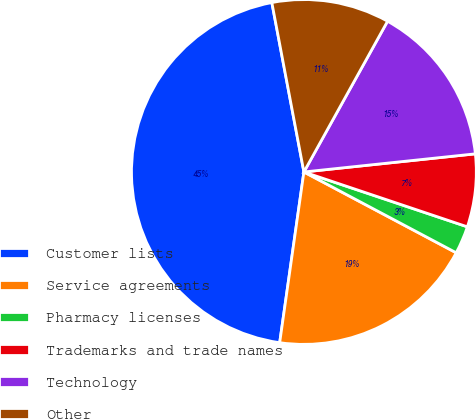<chart> <loc_0><loc_0><loc_500><loc_500><pie_chart><fcel>Customer lists<fcel>Service agreements<fcel>Pharmacy licenses<fcel>Trademarks and trade names<fcel>Technology<fcel>Other<nl><fcel>44.78%<fcel>19.48%<fcel>2.61%<fcel>6.83%<fcel>15.26%<fcel>11.04%<nl></chart> 